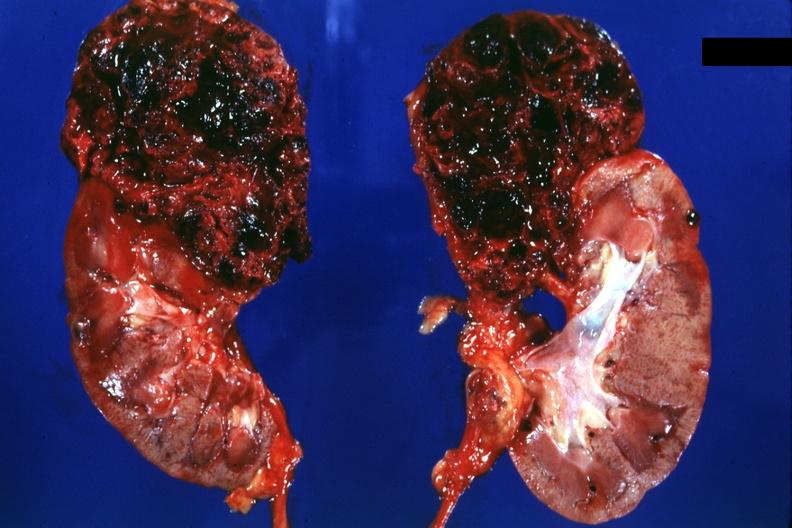s renal cell carcinoma present?
Answer the question using a single word or phrase. Yes 